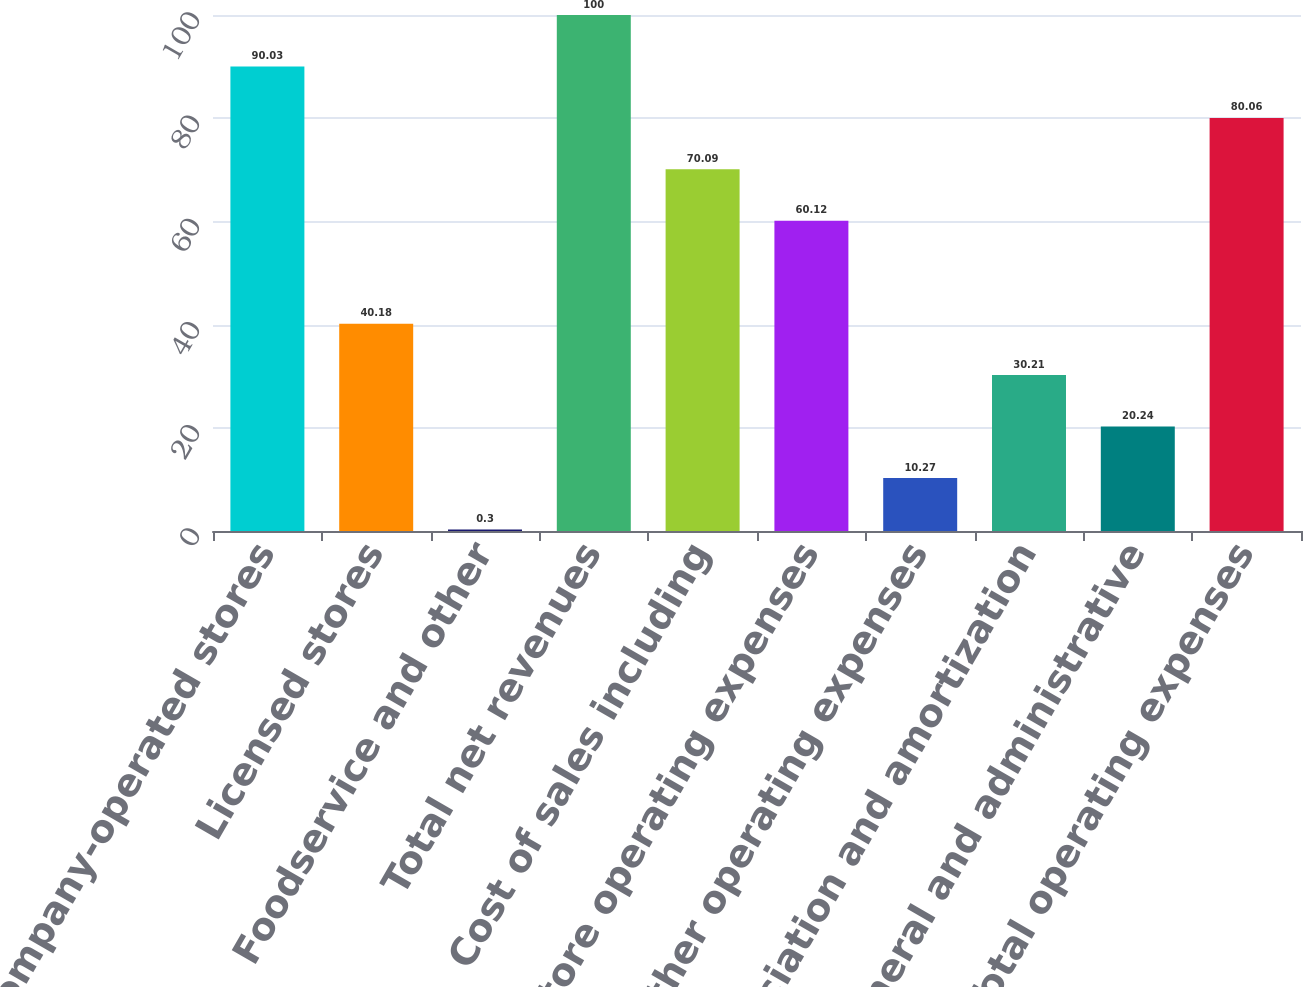Convert chart. <chart><loc_0><loc_0><loc_500><loc_500><bar_chart><fcel>Company-operated stores<fcel>Licensed stores<fcel>Foodservice and other<fcel>Total net revenues<fcel>Cost of sales including<fcel>Store operating expenses<fcel>Other operating expenses<fcel>Depreciation and amortization<fcel>General and administrative<fcel>Total operating expenses<nl><fcel>90.03<fcel>40.18<fcel>0.3<fcel>100<fcel>70.09<fcel>60.12<fcel>10.27<fcel>30.21<fcel>20.24<fcel>80.06<nl></chart> 